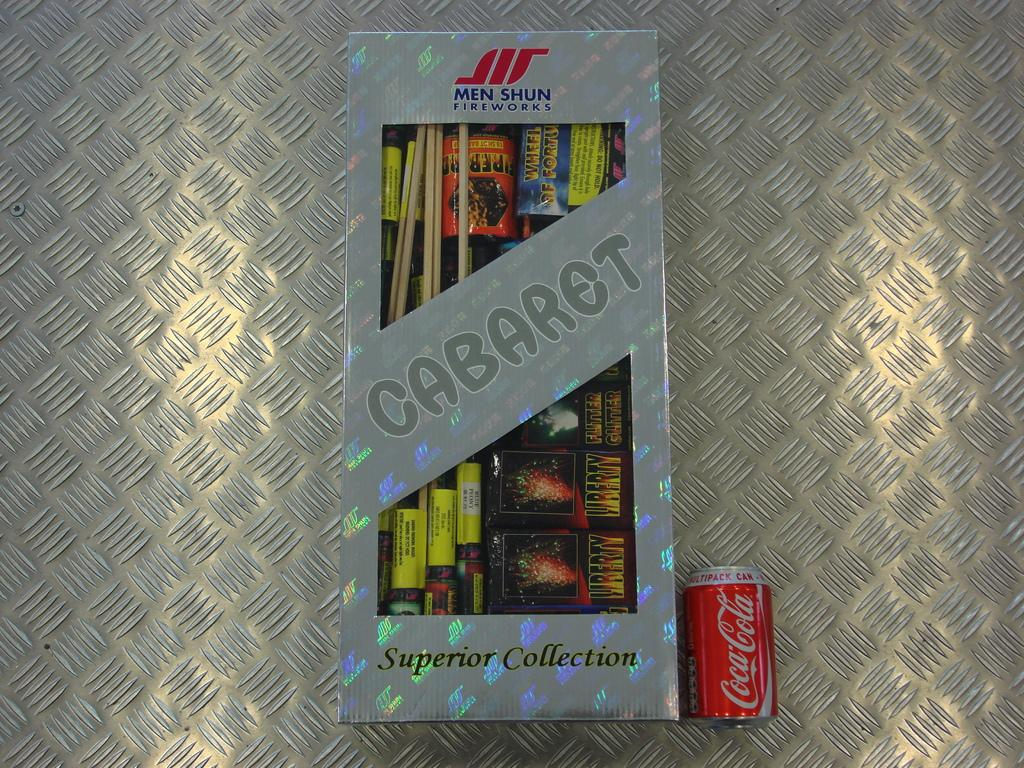<image>
Render a clear and concise summary of the photo. a box that is labeled 'men shun cabaret superior collection' 